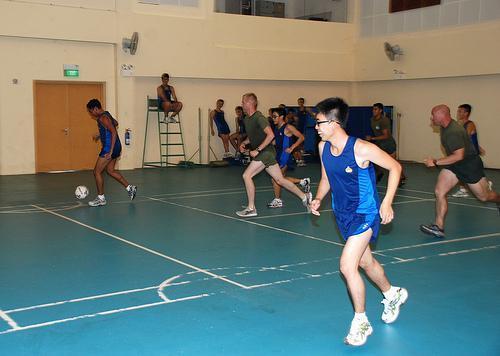How many people are wearing glasses?
Give a very brief answer. 2. 